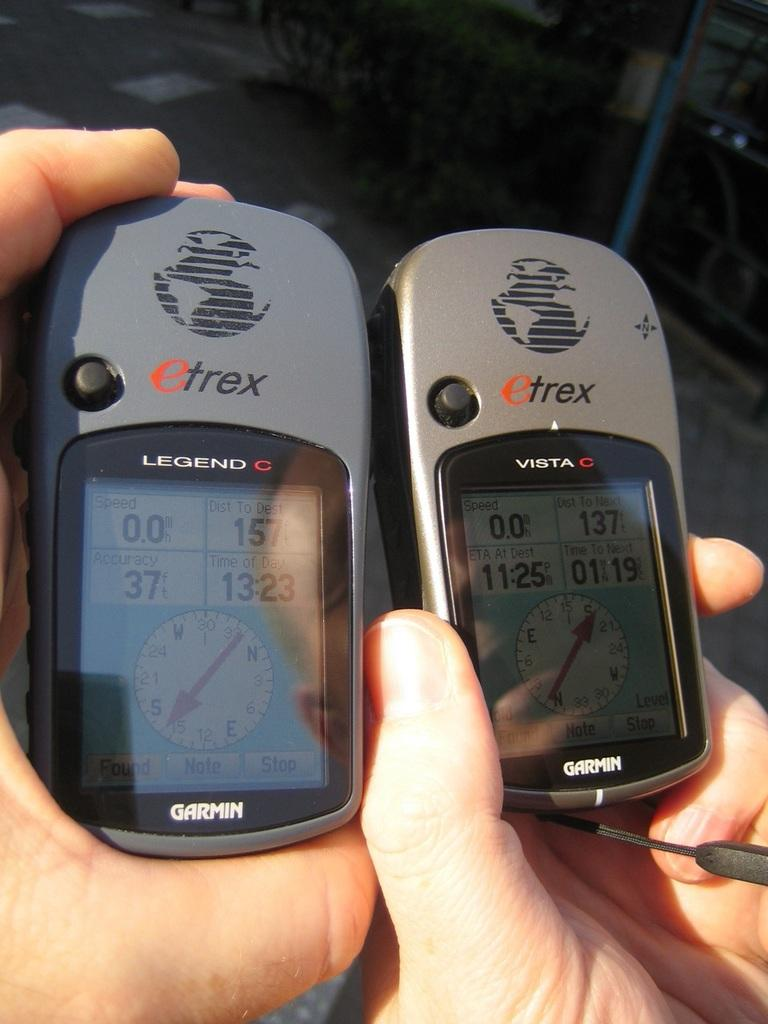<image>
Provide a brief description of the given image. Both brands of digital devices are made by etrex. 